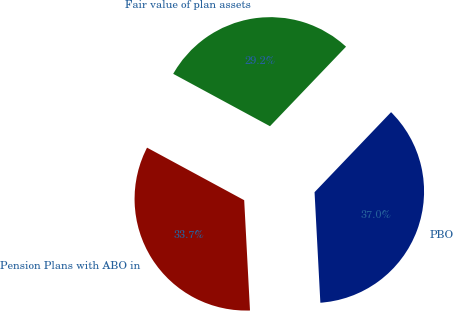Convert chart. <chart><loc_0><loc_0><loc_500><loc_500><pie_chart><fcel>PBO<fcel>Fair value of plan assets<fcel>Pension Plans with ABO in<nl><fcel>37.02%<fcel>29.25%<fcel>33.73%<nl></chart> 